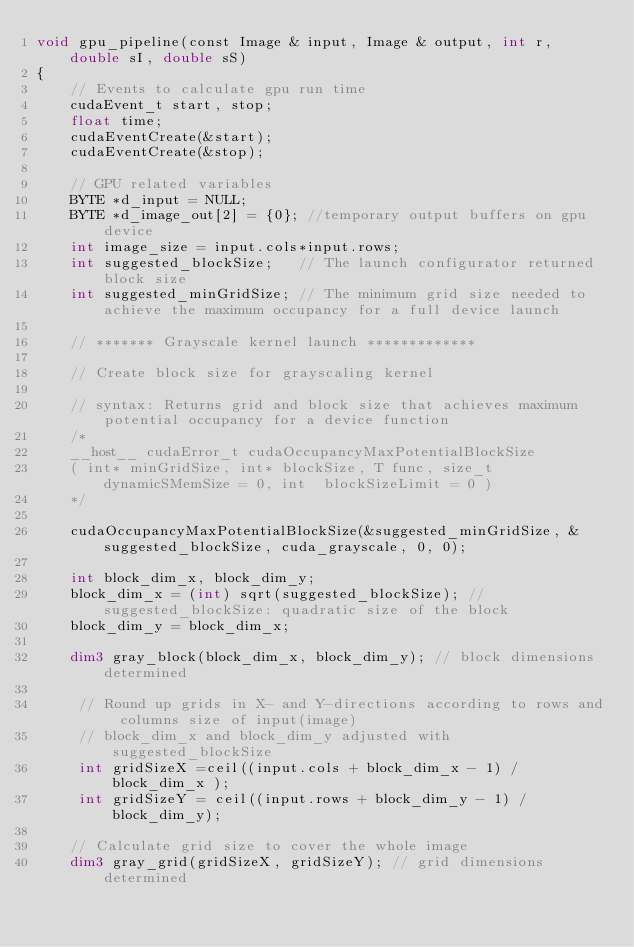<code> <loc_0><loc_0><loc_500><loc_500><_Cuda_>void gpu_pipeline(const Image & input, Image & output, int r, double sI, double sS)
{
	// Events to calculate gpu run time
	cudaEvent_t start, stop;
	float time;
	cudaEventCreate(&start);
	cudaEventCreate(&stop);

	// GPU related variables
	BYTE *d_input = NULL;
	BYTE *d_image_out[2] = {0}; //temporary output buffers on gpu device
	int image_size = input.cols*input.rows;
	int suggested_blockSize;   // The launch configurator returned block size
	int suggested_minGridSize; // The minimum grid size needed to achieve the maximum occupancy for a full device launch

	// ******* Grayscale kernel launch *************

	// Create block size for grayscaling kernel

	// syntax: Returns grid and block size that achieves maximum potential occupancy for a device function
	/*
	__host__ cudaError_t cudaOccupancyMaxPotentialBlockSize
	( int* minGridSize, int* blockSize, T func, size_t dynamicSMemSize = 0, int  blockSizeLimit = 0 )
	*/

	cudaOccupancyMaxPotentialBlockSize(&suggested_minGridSize, &suggested_blockSize, cuda_grayscale, 0, 0);

	int block_dim_x, block_dim_y;
	block_dim_x = (int) sqrt(suggested_blockSize); // suggested_blockSize: quadratic size of the block
	block_dim_y = block_dim_x;

	dim3 gray_block(block_dim_x, block_dim_y); // block dimensions determined

	 // Round up grids in X- and Y-directions according to rows and columns size of input(image)
	 // block_dim_x and block_dim_y adjusted with suggested_blockSize
	 int gridSizeX =ceil((input.cols + block_dim_x - 1) / block_dim_x );
	 int gridSizeY = ceil((input.rows + block_dim_y - 1) / block_dim_y);

    // Calculate grid size to cover the whole image
    dim3 gray_grid(gridSizeX, gridSizeY); // grid dimensions determined
</code> 